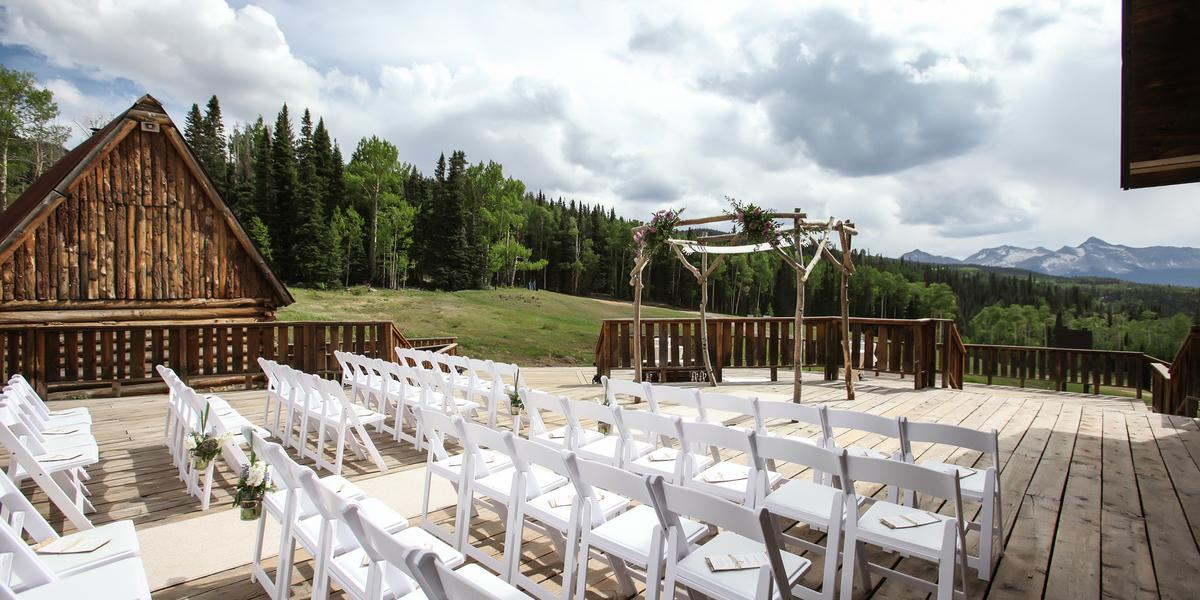Considering the arrangement of chairs and the position of the arch, what might be the maximum number of guests expected at this event, and how does the layout ensure that all guests will have a clear view of the ceremony? The photo clearly shows 72 chairs set up in a gracefully arching semi-circle pattern, hinting at an expected maximum of 72 guests. This thoughtful arrangement not only facilitates a close, intimate setting but also ensures that each guest has an unrestricted view of the central arch and ceremony space. The chairs are positioned wide apart along the aisle, which successfully avoids any line-of-sight obstructions, ensuring that the breathtaking backdrop of the mountains remains in view for everyone, thereby enhancing the ceremonial experience. 